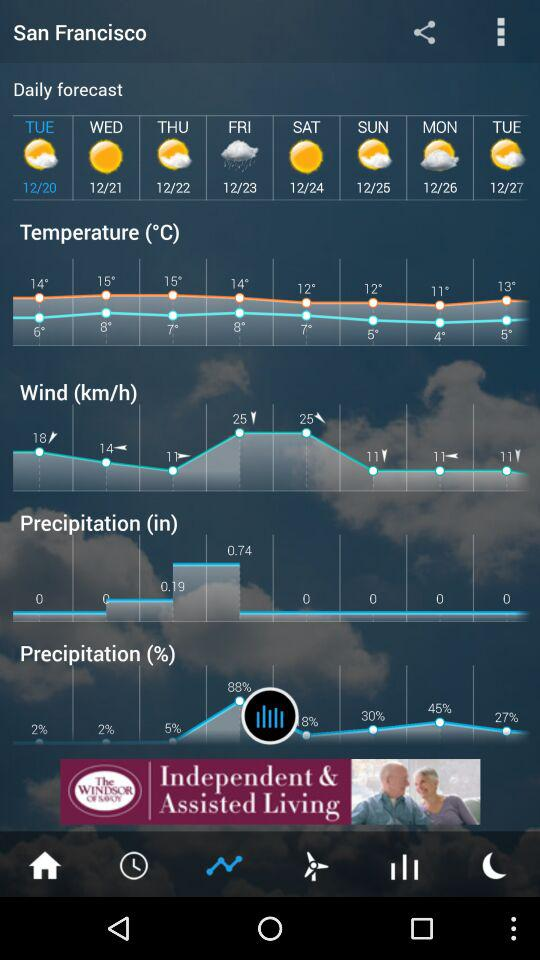What is the unit of temperature? The unit of temperature is °C. 